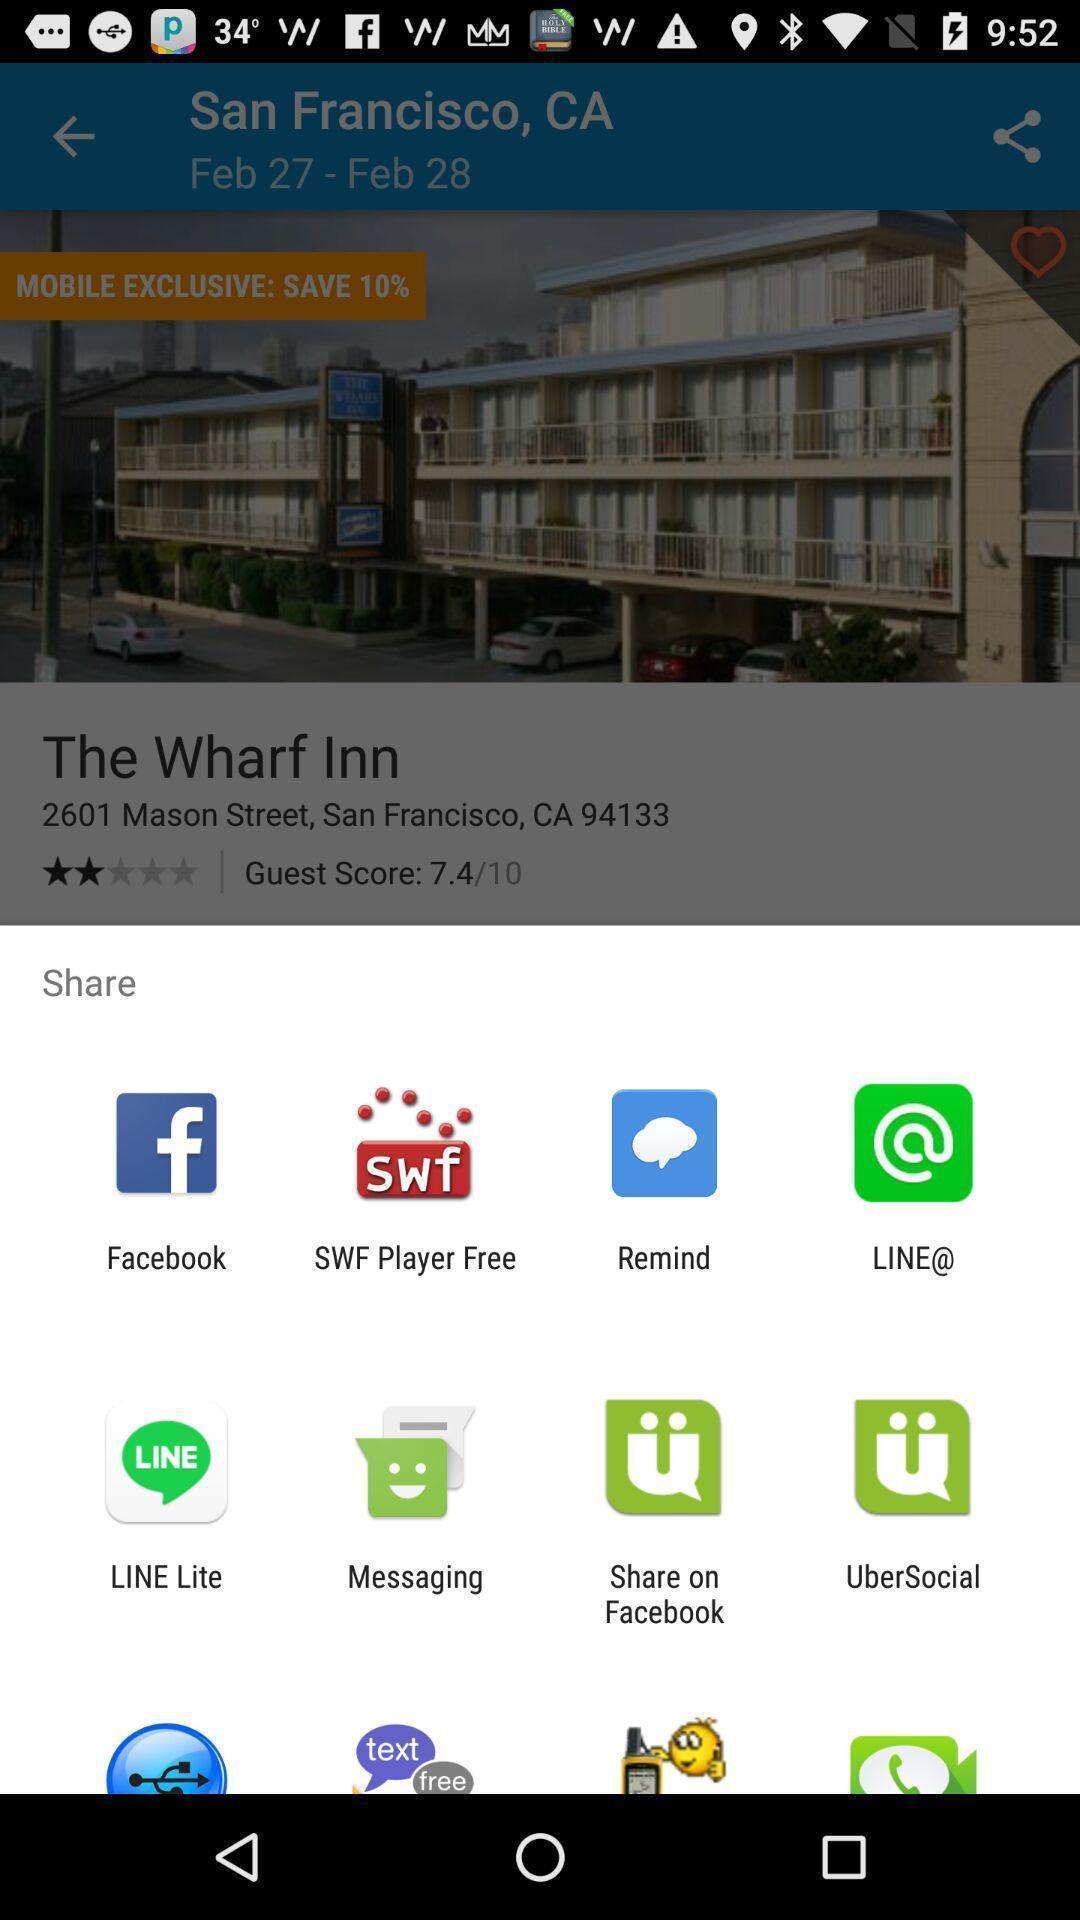What is the overall content of this screenshot? Popup showing different options to share the file. 